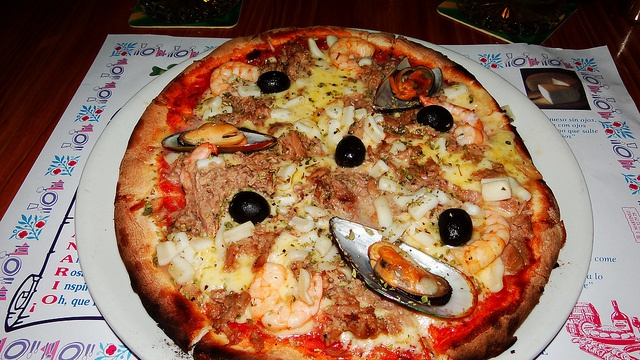Describe the objects in this image and their specific colors. I can see pizza in black, brown, tan, and maroon tones and dining table in black, darkgray, lightgray, and gray tones in this image. 